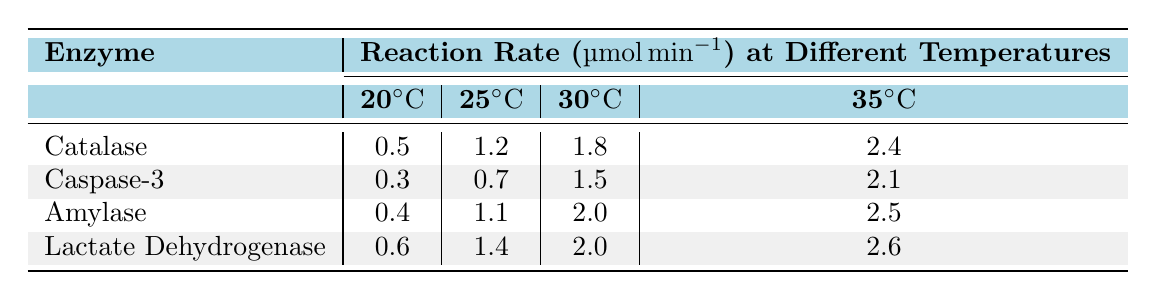What is the reaction rate of Catalase at 30°C? The table indicates that the reaction rate for Catalase at 30°C is listed directly in the corresponding cell, which shows a value of 1.8 µmol/min.
Answer: 1.8 µmol/min What is the highest reaction rate among all enzymes at 35°C? Looking at the reaction rates for each enzyme at 35°C, the values are 2.4 (Catalase), 2.1 (Caspase-3), 2.5 (Amylase), and 2.6 (Lactate Dehydrogenase). The highest among these is 2.6 µmol/min for Lactate Dehydrogenase.
Answer: 2.6 µmol/min What is the average reaction rate for Amylase across all temperatures? The reaction rates for Amylase at the respective temperatures are 0.4, 1.1, 2.0, and 2.5. To find the average, sum these values (0.4 + 1.1 + 2.0 + 2.5 = 6.0) and then divide by the number of temperatures (4): 6.0 / 4 = 1.5.
Answer: 1.5 µmol/min Is the reaction rate of Caspase-3 at 25°C higher than that of Lactate Dehydrogenase at 20°C? The reaction rate for Caspase-3 at 25°C is 0.7 µmol/min, while the reaction rate for Lactate Dehydrogenase at 20°C is 0.6 µmol/min. Since 0.7 is greater than 0.6, the statement is true.
Answer: Yes What is the difference in reaction rates between Amylase at 30°C and Catalase at 20°C? The reaction rate for Amylase at 30°C is 2.0 µmol/min, and for Catalase at 20°C it is 0.5 µmol/min. The difference is calculated by subtracting: 2.0 - 0.5 = 1.5.
Answer: 1.5 µmol/min Which enzyme shows the smallest increase in reaction rate from 20°C to 25°C? The increases from 20°C to 25°C for each enzyme are Catalase (1.2 - 0.5 = 0.7), Caspase-3 (0.7 - 0.3 = 0.4), Amylase (1.1 - 0.4 = 0.7), and Lactate Dehydrogenase (1.4 - 0.6 = 0.8). The smallest increase is 0.4 for Caspase-3.
Answer: Caspase-3 What trend do you observe regarding reaction rates as temperature increases for all enzymes? By examining the table, it is clear that as temperature increases from 20°C to 35°C, the reaction rates for all enzymes consistently increase, indicating a positive correlation between temperature and reaction rates.
Answer: The trend is an increase in reaction rates with temperature 